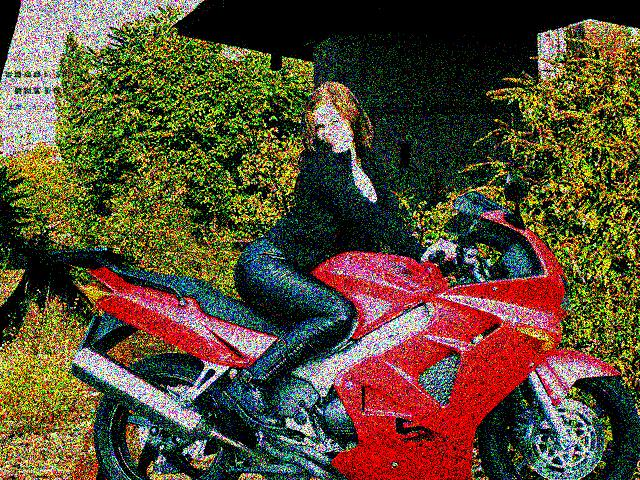What type of vehicle is the person sitting on? The individual is sitting on what appears to be a sport motorcycle, which is often characterized by its aerodynamic shape, high-performance engine, and vibrant red color in this particular case. 